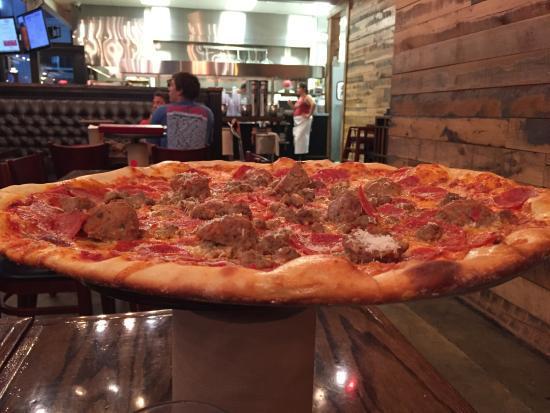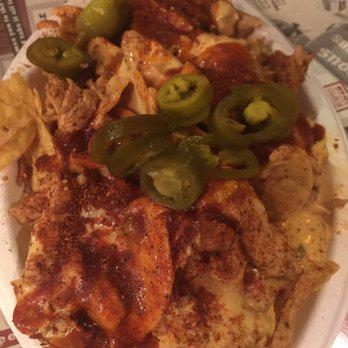The first image is the image on the left, the second image is the image on the right. Assess this claim about the two images: "One image shows a round pizza in a round pan with no slices removed, and the other image shows a pizza slice that is not joined to the rest of the pizza.". Correct or not? Answer yes or no. No. The first image is the image on the left, the second image is the image on the right. Analyze the images presented: Is the assertion "In at least one image there is a pepperoni pizza with a serving utenical underneath at least one slice." valid? Answer yes or no. No. 